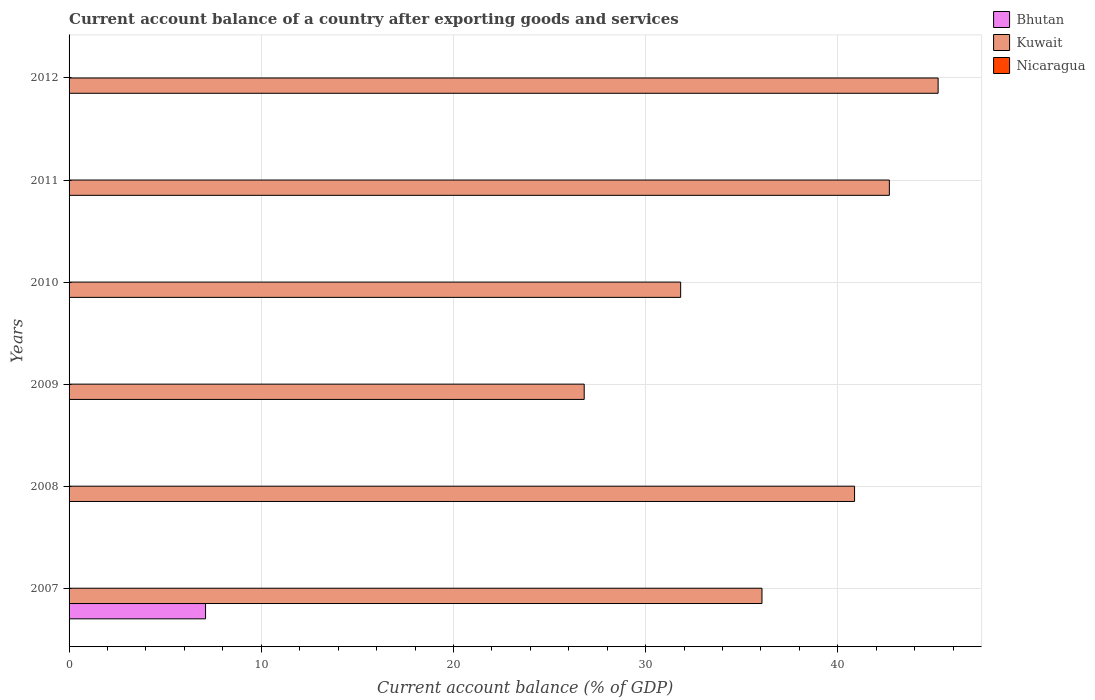Are the number of bars on each tick of the Y-axis equal?
Ensure brevity in your answer.  No. How many bars are there on the 5th tick from the top?
Ensure brevity in your answer.  1. What is the account balance in Kuwait in 2010?
Your answer should be compact. 31.82. Across all years, what is the maximum account balance in Bhutan?
Your response must be concise. 7.1. Across all years, what is the minimum account balance in Bhutan?
Make the answer very short. 0. In which year was the account balance in Kuwait maximum?
Give a very brief answer. 2012. What is the total account balance in Bhutan in the graph?
Provide a succinct answer. 7.1. What is the difference between the account balance in Kuwait in 2010 and that in 2011?
Offer a very short reply. -10.86. What is the difference between the account balance in Bhutan in 2009 and the account balance in Kuwait in 2007?
Your answer should be very brief. -36.05. In how many years, is the account balance in Nicaragua greater than 44 %?
Offer a very short reply. 0. What is the ratio of the account balance in Kuwait in 2008 to that in 2010?
Keep it short and to the point. 1.28. What is the difference between the highest and the second highest account balance in Kuwait?
Your response must be concise. 2.54. What is the difference between the highest and the lowest account balance in Kuwait?
Your answer should be compact. 18.41. In how many years, is the account balance in Nicaragua greater than the average account balance in Nicaragua taken over all years?
Keep it short and to the point. 0. How many bars are there?
Give a very brief answer. 7. How many years are there in the graph?
Provide a short and direct response. 6. Where does the legend appear in the graph?
Provide a succinct answer. Top right. How many legend labels are there?
Provide a short and direct response. 3. How are the legend labels stacked?
Your answer should be very brief. Vertical. What is the title of the graph?
Offer a terse response. Current account balance of a country after exporting goods and services. What is the label or title of the X-axis?
Give a very brief answer. Current account balance (% of GDP). What is the label or title of the Y-axis?
Ensure brevity in your answer.  Years. What is the Current account balance (% of GDP) of Bhutan in 2007?
Your response must be concise. 7.1. What is the Current account balance (% of GDP) of Kuwait in 2007?
Your answer should be very brief. 36.05. What is the Current account balance (% of GDP) in Nicaragua in 2007?
Ensure brevity in your answer.  0. What is the Current account balance (% of GDP) of Bhutan in 2008?
Your response must be concise. 0. What is the Current account balance (% of GDP) in Kuwait in 2008?
Offer a very short reply. 40.87. What is the Current account balance (% of GDP) of Bhutan in 2009?
Ensure brevity in your answer.  0. What is the Current account balance (% of GDP) of Kuwait in 2009?
Make the answer very short. 26.8. What is the Current account balance (% of GDP) of Nicaragua in 2009?
Keep it short and to the point. 0. What is the Current account balance (% of GDP) of Bhutan in 2010?
Your response must be concise. 0. What is the Current account balance (% of GDP) of Kuwait in 2010?
Provide a succinct answer. 31.82. What is the Current account balance (% of GDP) of Bhutan in 2011?
Give a very brief answer. 0. What is the Current account balance (% of GDP) in Kuwait in 2011?
Give a very brief answer. 42.68. What is the Current account balance (% of GDP) in Nicaragua in 2011?
Provide a short and direct response. 0. What is the Current account balance (% of GDP) of Bhutan in 2012?
Your answer should be very brief. 0. What is the Current account balance (% of GDP) in Kuwait in 2012?
Your response must be concise. 45.22. Across all years, what is the maximum Current account balance (% of GDP) of Bhutan?
Ensure brevity in your answer.  7.1. Across all years, what is the maximum Current account balance (% of GDP) of Kuwait?
Offer a very short reply. 45.22. Across all years, what is the minimum Current account balance (% of GDP) in Bhutan?
Provide a succinct answer. 0. Across all years, what is the minimum Current account balance (% of GDP) in Kuwait?
Keep it short and to the point. 26.8. What is the total Current account balance (% of GDP) of Bhutan in the graph?
Offer a very short reply. 7.1. What is the total Current account balance (% of GDP) in Kuwait in the graph?
Your response must be concise. 223.44. What is the total Current account balance (% of GDP) of Nicaragua in the graph?
Your answer should be very brief. 0. What is the difference between the Current account balance (% of GDP) of Kuwait in 2007 and that in 2008?
Keep it short and to the point. -4.82. What is the difference between the Current account balance (% of GDP) in Kuwait in 2007 and that in 2009?
Your response must be concise. 9.25. What is the difference between the Current account balance (% of GDP) in Kuwait in 2007 and that in 2010?
Provide a succinct answer. 4.23. What is the difference between the Current account balance (% of GDP) in Kuwait in 2007 and that in 2011?
Ensure brevity in your answer.  -6.63. What is the difference between the Current account balance (% of GDP) of Kuwait in 2007 and that in 2012?
Your answer should be very brief. -9.16. What is the difference between the Current account balance (% of GDP) in Kuwait in 2008 and that in 2009?
Provide a succinct answer. 14.07. What is the difference between the Current account balance (% of GDP) in Kuwait in 2008 and that in 2010?
Provide a short and direct response. 9.05. What is the difference between the Current account balance (% of GDP) of Kuwait in 2008 and that in 2011?
Offer a terse response. -1.81. What is the difference between the Current account balance (% of GDP) in Kuwait in 2008 and that in 2012?
Your answer should be very brief. -4.35. What is the difference between the Current account balance (% of GDP) of Kuwait in 2009 and that in 2010?
Give a very brief answer. -5.02. What is the difference between the Current account balance (% of GDP) in Kuwait in 2009 and that in 2011?
Provide a short and direct response. -15.88. What is the difference between the Current account balance (% of GDP) in Kuwait in 2009 and that in 2012?
Offer a very short reply. -18.41. What is the difference between the Current account balance (% of GDP) of Kuwait in 2010 and that in 2011?
Keep it short and to the point. -10.86. What is the difference between the Current account balance (% of GDP) of Kuwait in 2010 and that in 2012?
Your answer should be very brief. -13.4. What is the difference between the Current account balance (% of GDP) of Kuwait in 2011 and that in 2012?
Keep it short and to the point. -2.54. What is the difference between the Current account balance (% of GDP) in Bhutan in 2007 and the Current account balance (% of GDP) in Kuwait in 2008?
Give a very brief answer. -33.77. What is the difference between the Current account balance (% of GDP) of Bhutan in 2007 and the Current account balance (% of GDP) of Kuwait in 2009?
Provide a short and direct response. -19.7. What is the difference between the Current account balance (% of GDP) of Bhutan in 2007 and the Current account balance (% of GDP) of Kuwait in 2010?
Ensure brevity in your answer.  -24.72. What is the difference between the Current account balance (% of GDP) of Bhutan in 2007 and the Current account balance (% of GDP) of Kuwait in 2011?
Offer a terse response. -35.58. What is the difference between the Current account balance (% of GDP) of Bhutan in 2007 and the Current account balance (% of GDP) of Kuwait in 2012?
Provide a succinct answer. -38.11. What is the average Current account balance (% of GDP) of Bhutan per year?
Provide a succinct answer. 1.18. What is the average Current account balance (% of GDP) of Kuwait per year?
Provide a short and direct response. 37.24. In the year 2007, what is the difference between the Current account balance (% of GDP) of Bhutan and Current account balance (% of GDP) of Kuwait?
Ensure brevity in your answer.  -28.95. What is the ratio of the Current account balance (% of GDP) in Kuwait in 2007 to that in 2008?
Your answer should be very brief. 0.88. What is the ratio of the Current account balance (% of GDP) in Kuwait in 2007 to that in 2009?
Offer a very short reply. 1.35. What is the ratio of the Current account balance (% of GDP) in Kuwait in 2007 to that in 2010?
Your response must be concise. 1.13. What is the ratio of the Current account balance (% of GDP) of Kuwait in 2007 to that in 2011?
Your answer should be very brief. 0.84. What is the ratio of the Current account balance (% of GDP) of Kuwait in 2007 to that in 2012?
Provide a succinct answer. 0.8. What is the ratio of the Current account balance (% of GDP) of Kuwait in 2008 to that in 2009?
Ensure brevity in your answer.  1.52. What is the ratio of the Current account balance (% of GDP) of Kuwait in 2008 to that in 2010?
Provide a short and direct response. 1.28. What is the ratio of the Current account balance (% of GDP) of Kuwait in 2008 to that in 2011?
Make the answer very short. 0.96. What is the ratio of the Current account balance (% of GDP) of Kuwait in 2008 to that in 2012?
Your response must be concise. 0.9. What is the ratio of the Current account balance (% of GDP) in Kuwait in 2009 to that in 2010?
Your response must be concise. 0.84. What is the ratio of the Current account balance (% of GDP) of Kuwait in 2009 to that in 2011?
Provide a succinct answer. 0.63. What is the ratio of the Current account balance (% of GDP) of Kuwait in 2009 to that in 2012?
Ensure brevity in your answer.  0.59. What is the ratio of the Current account balance (% of GDP) of Kuwait in 2010 to that in 2011?
Your answer should be very brief. 0.75. What is the ratio of the Current account balance (% of GDP) in Kuwait in 2010 to that in 2012?
Your answer should be very brief. 0.7. What is the ratio of the Current account balance (% of GDP) of Kuwait in 2011 to that in 2012?
Your response must be concise. 0.94. What is the difference between the highest and the second highest Current account balance (% of GDP) in Kuwait?
Your response must be concise. 2.54. What is the difference between the highest and the lowest Current account balance (% of GDP) of Bhutan?
Your response must be concise. 7.1. What is the difference between the highest and the lowest Current account balance (% of GDP) of Kuwait?
Offer a terse response. 18.41. 